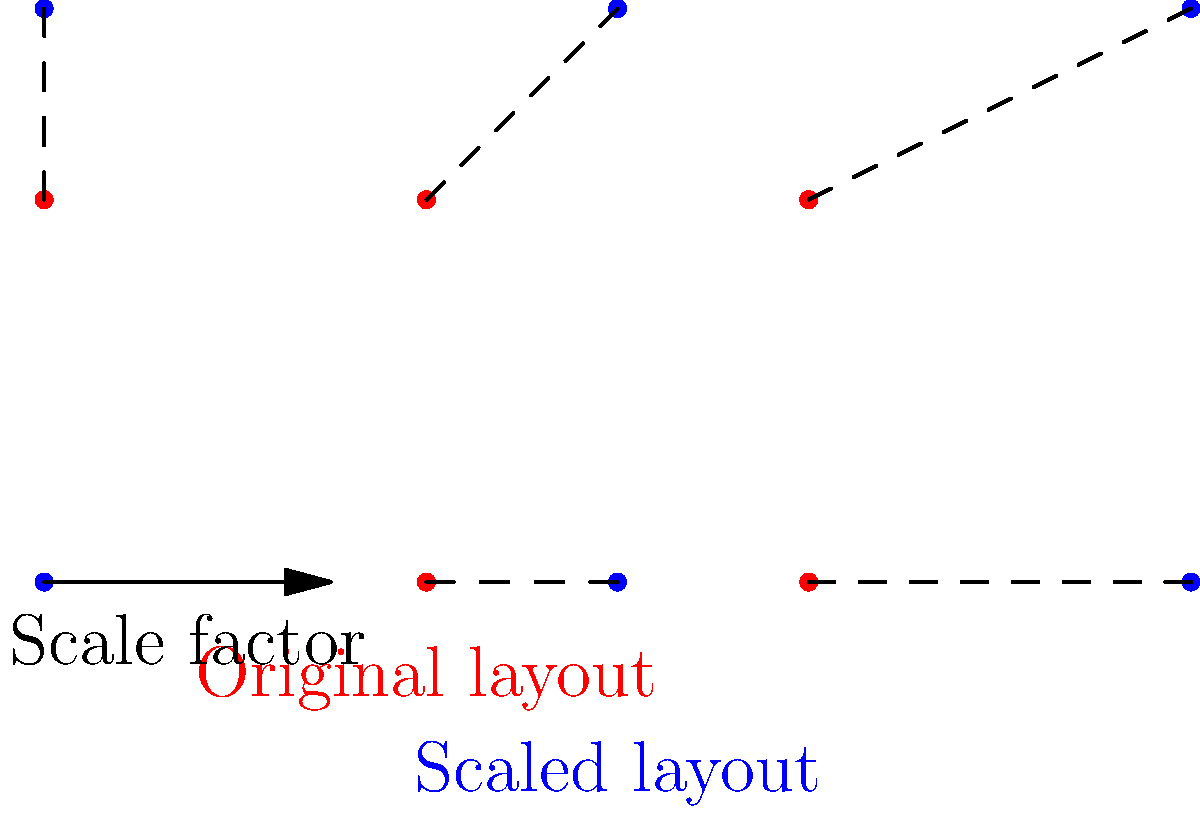A wind farm layout needs to be scaled up to maximize efficiency. The original layout has turbines placed in a 2x3 grid with 2 units between each turbine. If the new layout requires 3 units between each turbine, what is the scale factor used for this transformation? How does this scaling affect the total area covered by the wind farm? To solve this problem, we need to follow these steps:

1. Determine the scale factor:
   - Original distance between turbines: 2 units
   - New distance between turbines: 3 units
   - Scale factor = New distance / Original distance
   - Scale factor = 3 / 2 = 1.5

2. Calculate the effect on the total area:
   - Area is affected by the square of the scale factor
   - Let's call the original area A
   - New area = A * (scale factor)^2
   - New area = A * (1.5)^2 = 2.25A

3. Express the change in area:
   - Increase in area = New area - Original area
   - Increase in area = 2.25A - A = 1.25A
   - This represents a 125% increase in area

Therefore, the scale factor is 1.5, and the total area covered by the wind farm increases by 125% or 2.25 times the original area.
Answer: Scale factor: 1.5; Area increase: 125% 